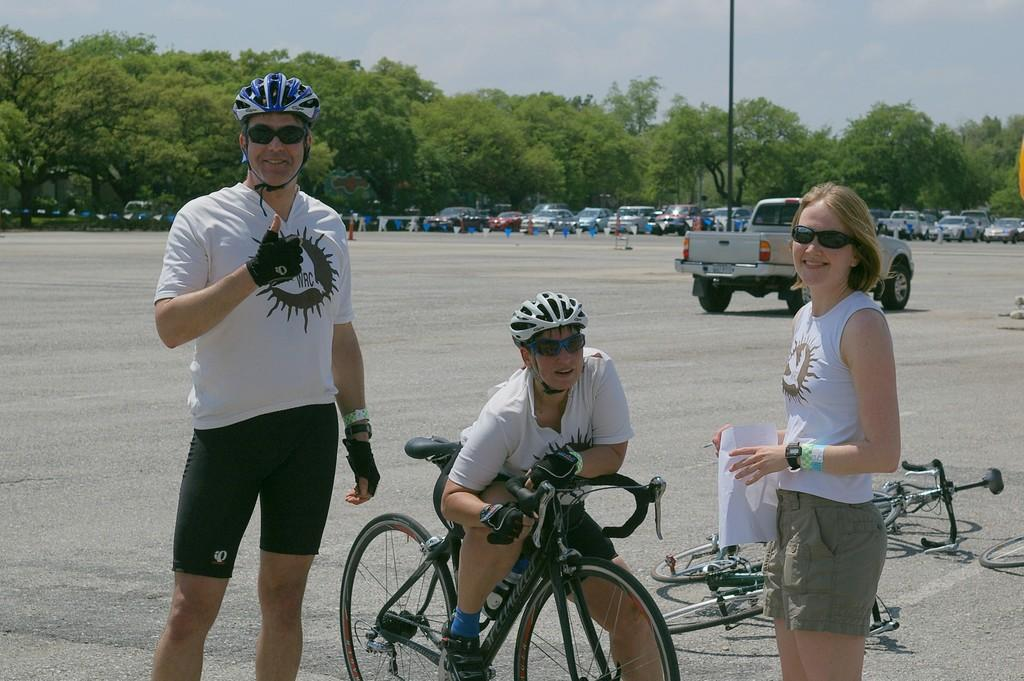How many people are in the image? There are two men and a woman in the image. What is one of the men doing in the image? One man is on a cycle. What can be seen in the background of the image? There are vehicles and trees in the background of the image. What is visible at the top of the image? The sky is visible in the image. What type of zinc is being used to educate the men in the image? There is no zinc or education present in the image; it features two men and a woman, one of whom is on a cycle, with vehicles, trees, and the sky visible in the background. 